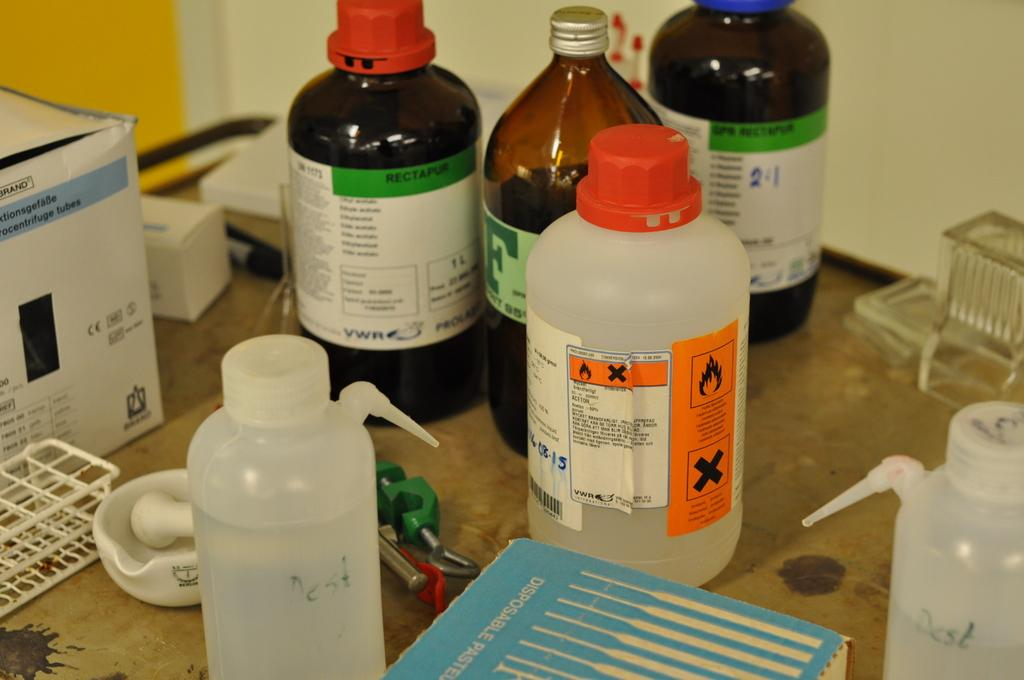<image>
Create a compact narrative representing the image presented. Chemicals in bottles from the company VWR are on a table near a mortar and pestle. 